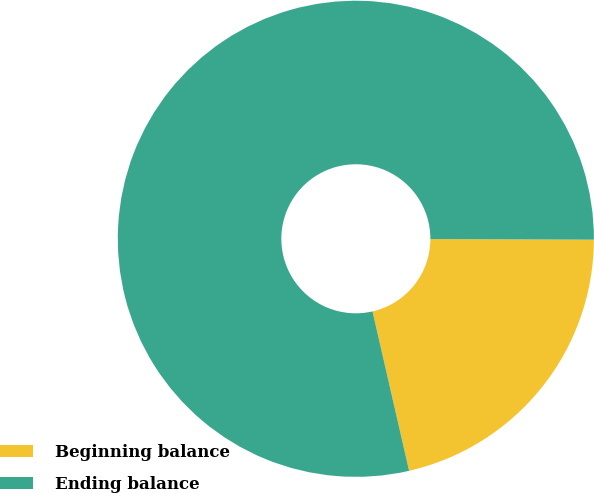Convert chart to OTSL. <chart><loc_0><loc_0><loc_500><loc_500><pie_chart><fcel>Beginning balance<fcel>Ending balance<nl><fcel>21.35%<fcel>78.65%<nl></chart> 